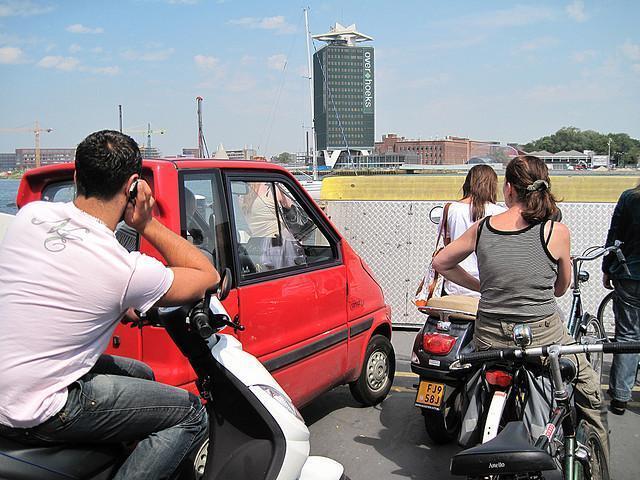How many girls are there?
Give a very brief answer. 2. How many people are visible?
Give a very brief answer. 5. How many bicycles are there?
Give a very brief answer. 2. How many motorcycles can you see?
Give a very brief answer. 2. How many big elephants are there?
Give a very brief answer. 0. 